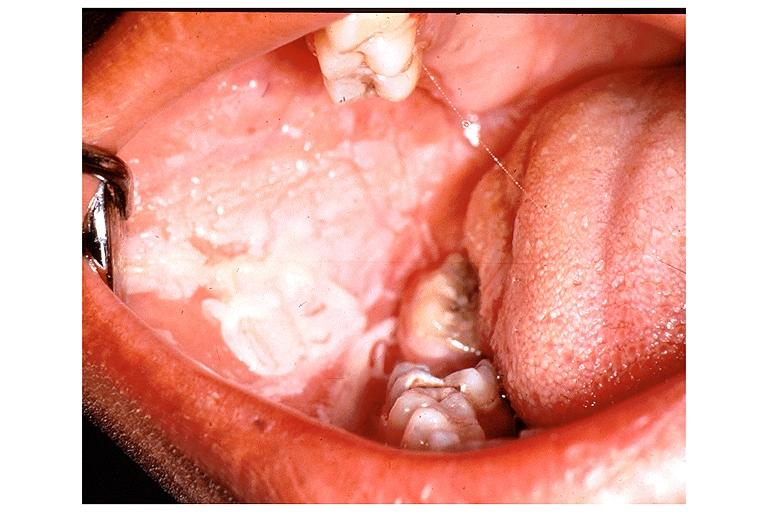what does this image show?
Answer the question using a single word or phrase. Chemical burn from topical asprin 